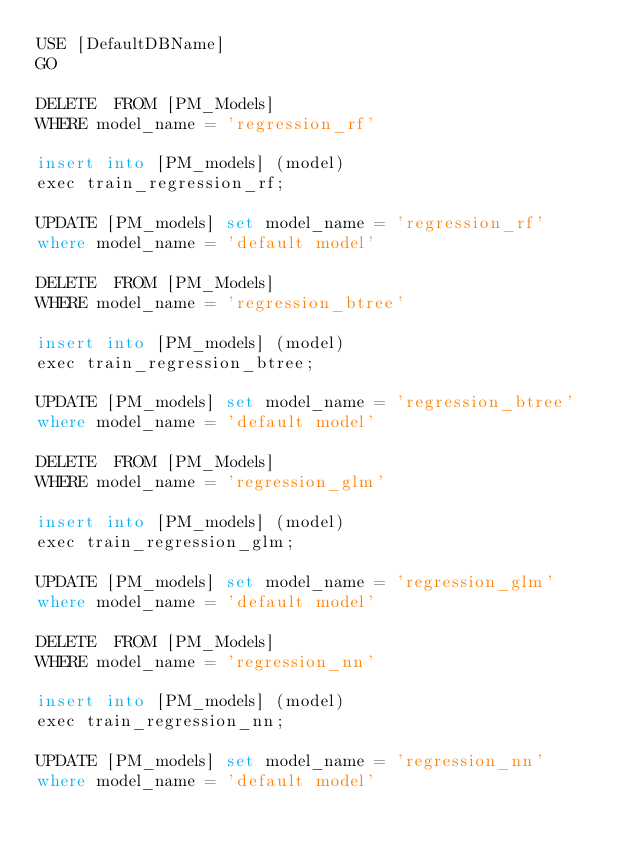Convert code to text. <code><loc_0><loc_0><loc_500><loc_500><_SQL_>USE [DefaultDBName]
GO

DELETE  FROM [PM_Models]
WHERE model_name = 'regression_rf'

insert into [PM_models] (model)
exec train_regression_rf;

UPDATE [PM_models] set model_name = 'regression_rf' 
where model_name = 'default model'

DELETE  FROM [PM_Models]
WHERE model_name = 'regression_btree'

insert into [PM_models] (model)
exec train_regression_btree;

UPDATE [PM_models] set model_name = 'regression_btree' 
where model_name = 'default model'

DELETE  FROM [PM_Models]
WHERE model_name = 'regression_glm'

insert into [PM_models] (model)
exec train_regression_glm;

UPDATE [PM_models] set model_name = 'regression_glm' 
where model_name = 'default model'

DELETE  FROM [PM_Models]
WHERE model_name = 'regression_nn'

insert into [PM_models] (model)
exec train_regression_nn;

UPDATE [PM_models] set model_name = 'regression_nn' 
where model_name = 'default model'
</code> 